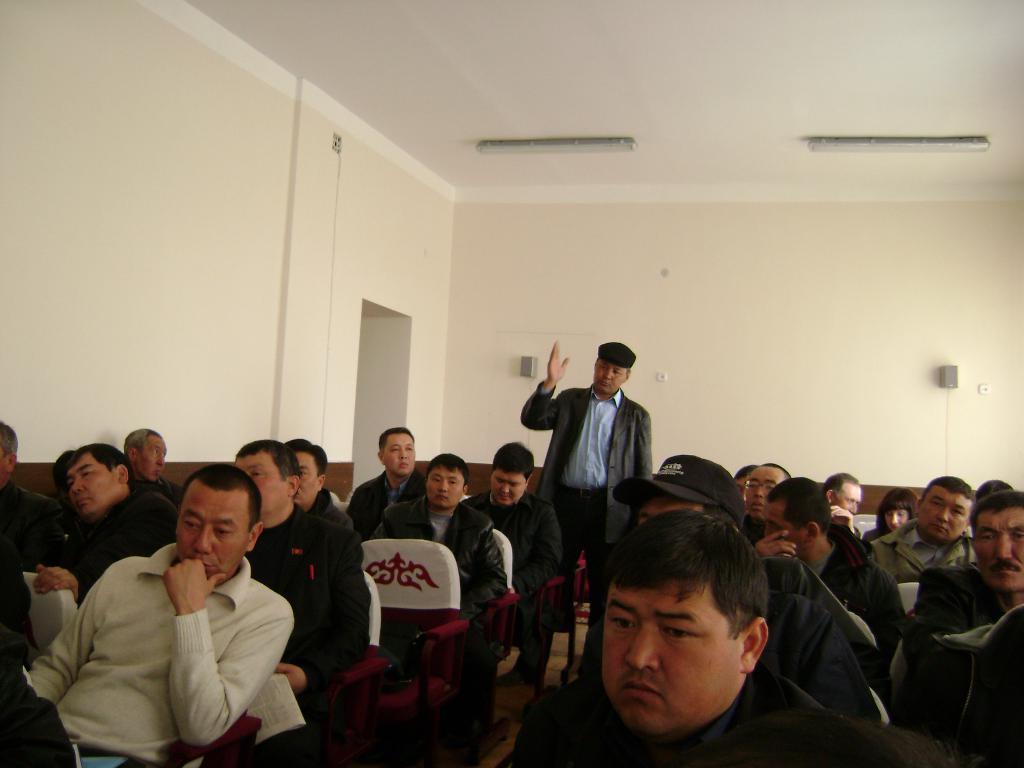Could you give a brief overview of what you see in this image? In this image there are people sitting on the chairs. In the center of the image there is a person standing on the floor. In the background of the image there are speakers. There is a wall. On the top of the image there are lights. 